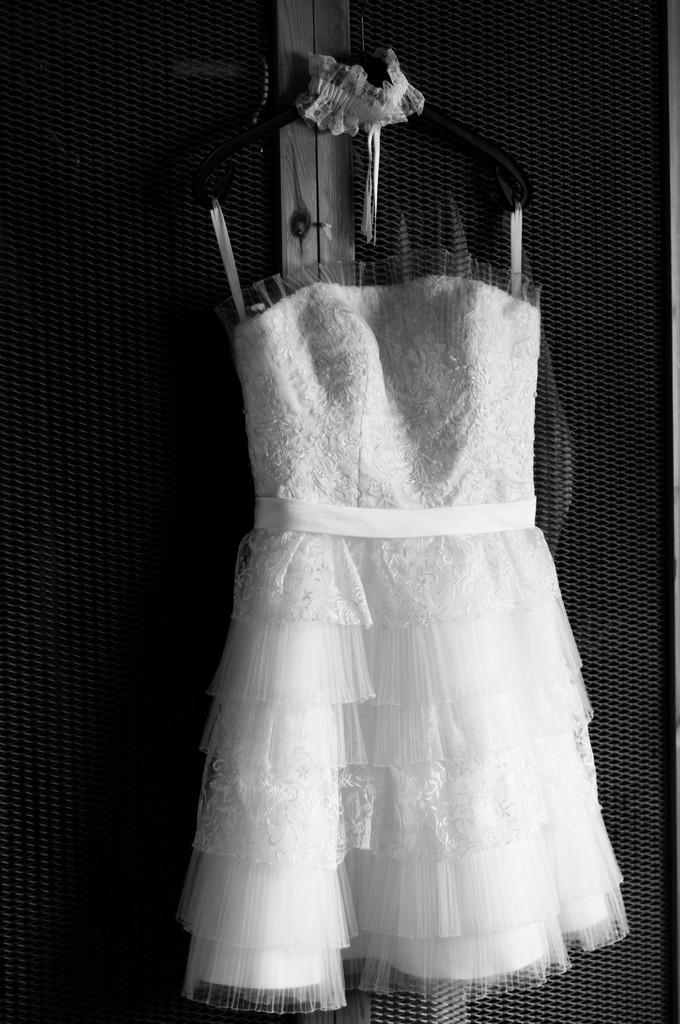How would you summarize this image in a sentence or two? This is a black and white picture of a frock hanging to a wall. 